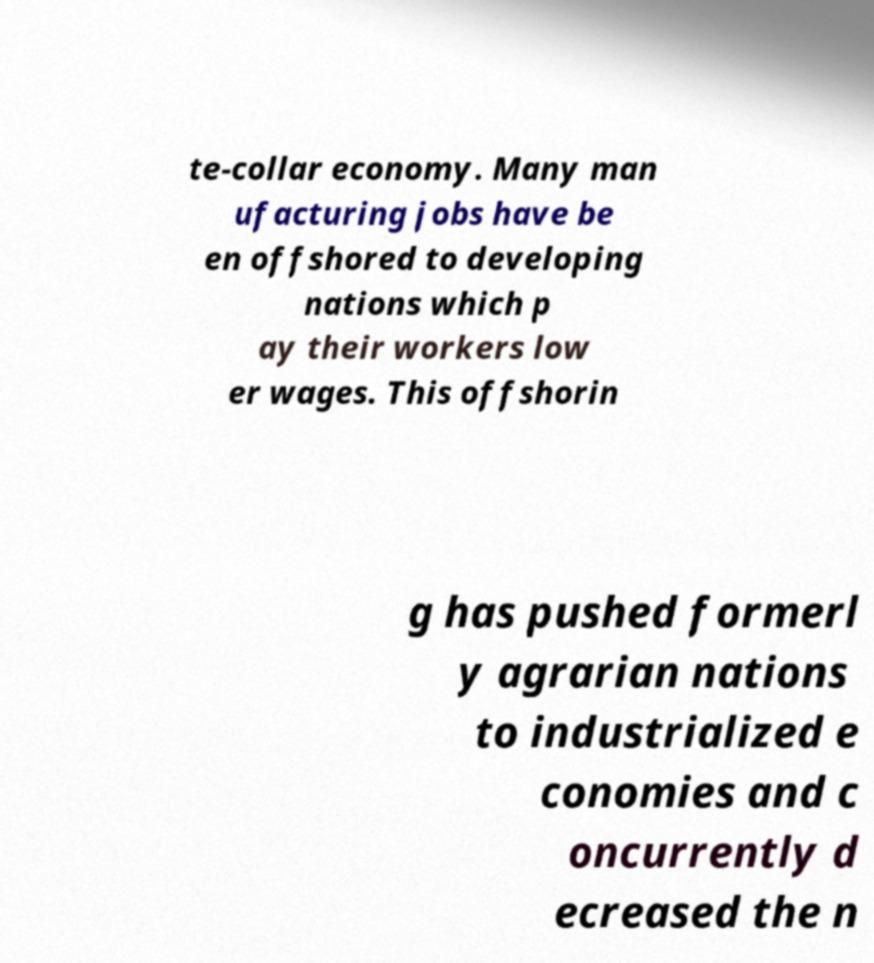What messages or text are displayed in this image? I need them in a readable, typed format. te-collar economy. Many man ufacturing jobs have be en offshored to developing nations which p ay their workers low er wages. This offshorin g has pushed formerl y agrarian nations to industrialized e conomies and c oncurrently d ecreased the n 